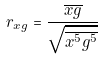Convert formula to latex. <formula><loc_0><loc_0><loc_500><loc_500>r _ { x g } = \frac { \overline { x g } } { \sqrt { \overline { x ^ { 5 } } \overline { g ^ { 5 } } } }</formula> 